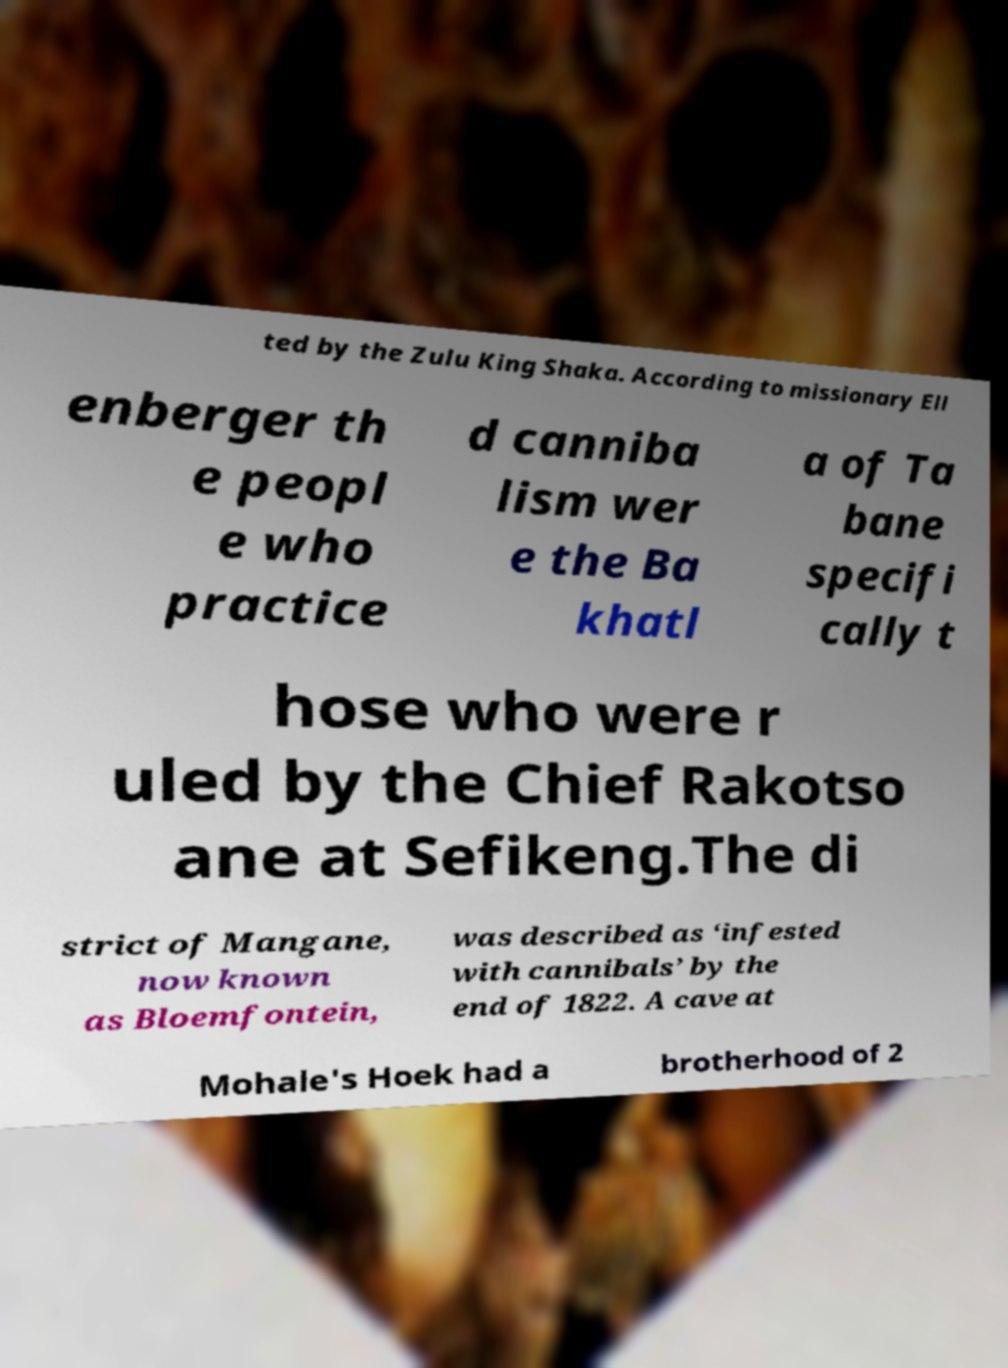Could you extract and type out the text from this image? ted by the Zulu King Shaka. According to missionary Ell enberger th e peopl e who practice d canniba lism wer e the Ba khatl a of Ta bane specifi cally t hose who were r uled by the Chief Rakotso ane at Sefikeng.The di strict of Mangane, now known as Bloemfontein, was described as ‘infested with cannibals’ by the end of 1822. A cave at Mohale's Hoek had a brotherhood of 2 